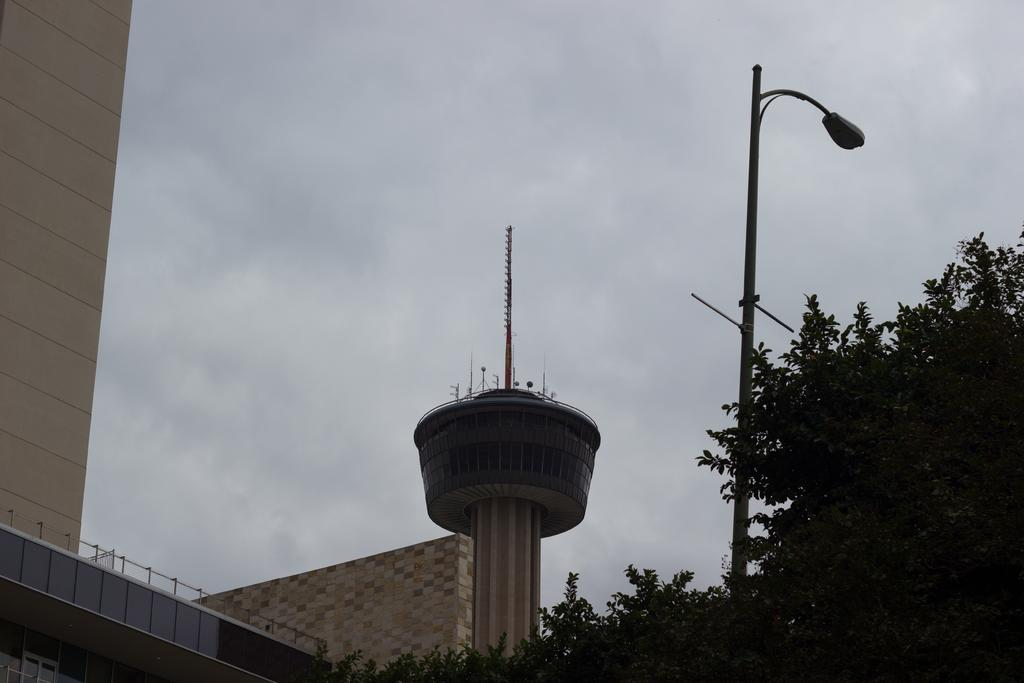What type of structure is present in the image? There is a building in the image. What other objects can be seen in the image? There are trees, a metal pole, a street light, and a tower in the image. What is visible in the background of the image? The sky is visible in the image. What type of music is being played by the potato in the image? There is no potato or music present in the image. 